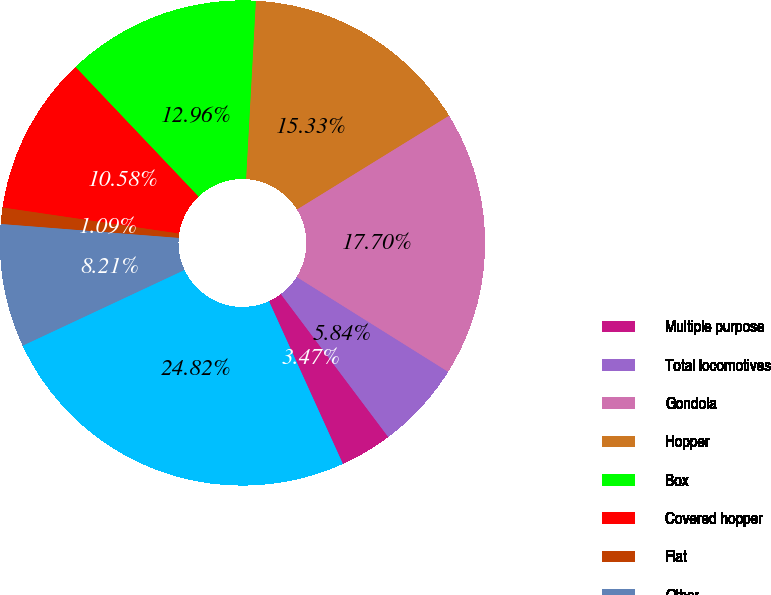Convert chart. <chart><loc_0><loc_0><loc_500><loc_500><pie_chart><fcel>Multiple purpose<fcel>Total locomotives<fcel>Gondola<fcel>Hopper<fcel>Box<fcel>Covered hopper<fcel>Flat<fcel>Other<fcel>Total freight cars<nl><fcel>3.47%<fcel>5.84%<fcel>17.7%<fcel>15.33%<fcel>12.96%<fcel>10.58%<fcel>1.09%<fcel>8.21%<fcel>24.82%<nl></chart> 